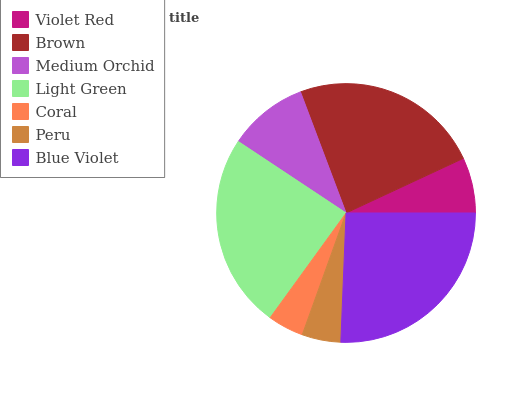Is Coral the minimum?
Answer yes or no. Yes. Is Blue Violet the maximum?
Answer yes or no. Yes. Is Brown the minimum?
Answer yes or no. No. Is Brown the maximum?
Answer yes or no. No. Is Brown greater than Violet Red?
Answer yes or no. Yes. Is Violet Red less than Brown?
Answer yes or no. Yes. Is Violet Red greater than Brown?
Answer yes or no. No. Is Brown less than Violet Red?
Answer yes or no. No. Is Medium Orchid the high median?
Answer yes or no. Yes. Is Medium Orchid the low median?
Answer yes or no. Yes. Is Blue Violet the high median?
Answer yes or no. No. Is Violet Red the low median?
Answer yes or no. No. 